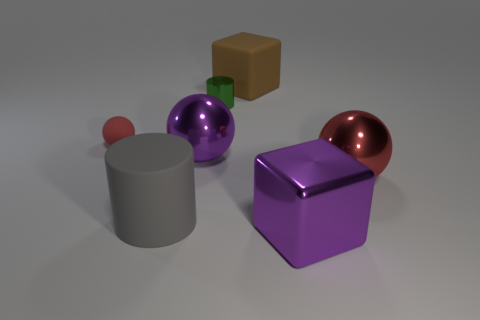How many red objects are the same size as the brown matte cube?
Provide a succinct answer. 1. There is another ball that is the same color as the tiny sphere; what size is it?
Provide a short and direct response. Large. What number of tiny objects are metallic objects or yellow metal spheres?
Your answer should be very brief. 1. How many big cylinders are there?
Keep it short and to the point. 1. Are there the same number of large brown objects right of the tiny green shiny object and purple metal cubes right of the big red shiny object?
Give a very brief answer. No. Are there any purple things to the left of the big brown block?
Provide a succinct answer. Yes. What color is the block right of the brown rubber block?
Ensure brevity in your answer.  Purple. There is a ball that is right of the big purple metal thing in front of the big gray matte thing; what is it made of?
Your answer should be compact. Metal. Is the number of large metallic spheres left of the large shiny block less than the number of red matte things to the left of the small ball?
Offer a very short reply. No. How many yellow things are either rubber blocks or large rubber cylinders?
Ensure brevity in your answer.  0. 